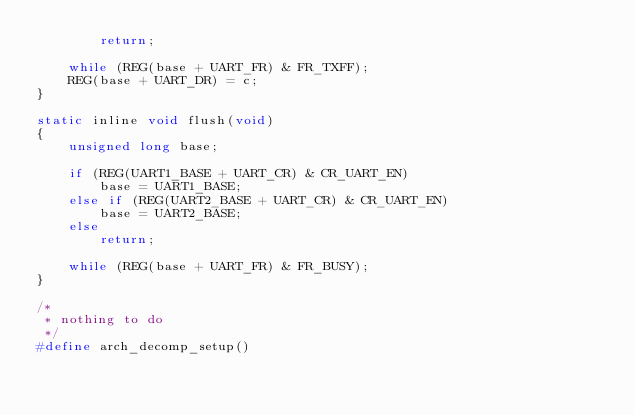<code> <loc_0><loc_0><loc_500><loc_500><_C_>		return;

	while (REG(base + UART_FR) & FR_TXFF);
	REG(base + UART_DR) = c;
}

static inline void flush(void)
{
	unsigned long base;

	if (REG(UART1_BASE + UART_CR) & CR_UART_EN)
		base = UART1_BASE;
	else if (REG(UART2_BASE + UART_CR) & CR_UART_EN)
		base = UART2_BASE;
	else
		return;

	while (REG(base + UART_FR) & FR_BUSY);
}

/*
 * nothing to do
 */
#define arch_decomp_setup()
</code> 